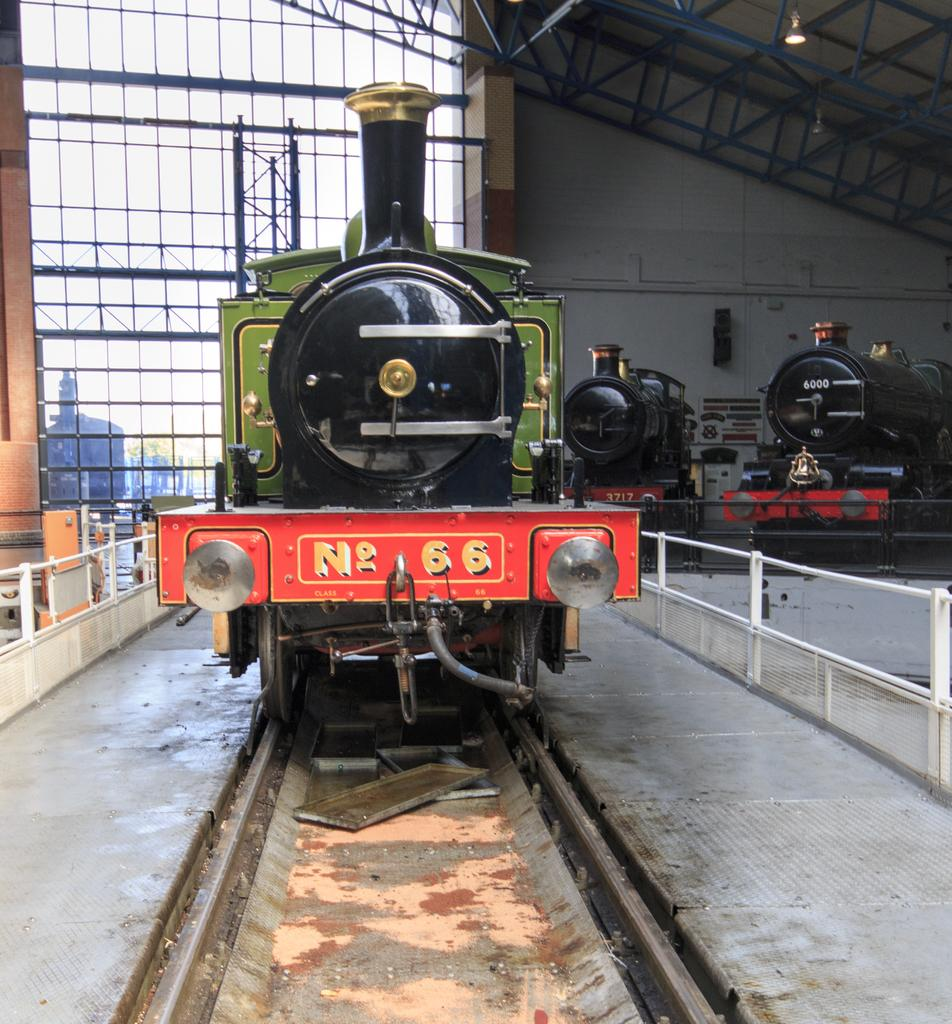What is the main subject of the image? The main subject of the image is a train. Where is the train located in the image? The train is on a railway track. What can be seen in the background of the image? In the background of the image, there are trains, fences, poles, glass, lights, and other objects. What type of cough medicine is visible in the image? There is no cough medicine present in the image. What kind of needle is being used to sew a jewel onto the train in the image? There is no needle or jewel present in the image; it features a train on a railway track and various background elements. 